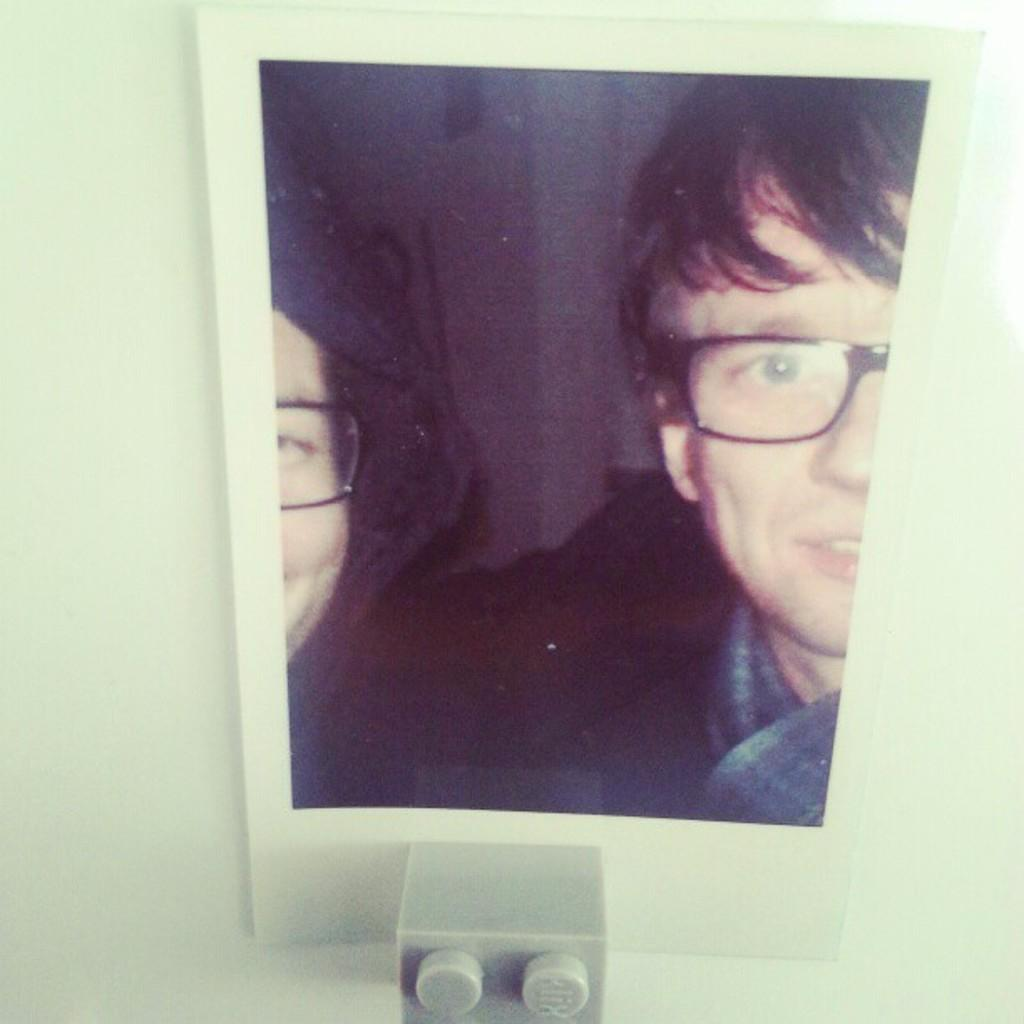What is the main subject of the image? The main subject of the image is a photo of two persons. What can be observed about the persons in the photo? Both persons in the photo are wearing spectacles. Is there anything else attached to or associated with the photo? Yes, there is an object attached to the photo. What type of pie is being served in the image? There is no pie present in the image; it features a photo of two persons wearing spectacles. What language are the persons in the photo speaking? The image does not provide any information about the language being spoken by the persons in the photo. 